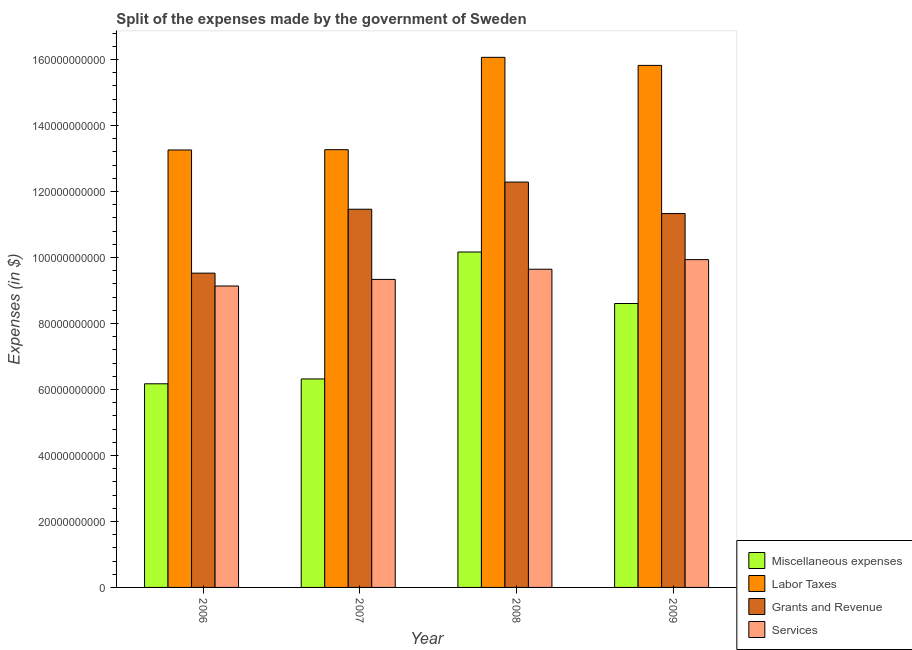How many bars are there on the 1st tick from the right?
Make the answer very short. 4. What is the label of the 2nd group of bars from the left?
Provide a short and direct response. 2007. In how many cases, is the number of bars for a given year not equal to the number of legend labels?
Your answer should be compact. 0. What is the amount spent on miscellaneous expenses in 2006?
Give a very brief answer. 6.17e+1. Across all years, what is the maximum amount spent on labor taxes?
Ensure brevity in your answer.  1.61e+11. Across all years, what is the minimum amount spent on services?
Make the answer very short. 9.14e+1. In which year was the amount spent on grants and revenue maximum?
Make the answer very short. 2008. In which year was the amount spent on services minimum?
Your answer should be compact. 2006. What is the total amount spent on services in the graph?
Your response must be concise. 3.81e+11. What is the difference between the amount spent on grants and revenue in 2007 and that in 2008?
Make the answer very short. -8.23e+09. What is the difference between the amount spent on grants and revenue in 2008 and the amount spent on miscellaneous expenses in 2007?
Ensure brevity in your answer.  8.23e+09. What is the average amount spent on services per year?
Keep it short and to the point. 9.51e+1. In how many years, is the amount spent on labor taxes greater than 52000000000 $?
Offer a very short reply. 4. What is the ratio of the amount spent on labor taxes in 2007 to that in 2008?
Provide a short and direct response. 0.83. Is the difference between the amount spent on miscellaneous expenses in 2006 and 2007 greater than the difference between the amount spent on grants and revenue in 2006 and 2007?
Offer a very short reply. No. What is the difference between the highest and the second highest amount spent on labor taxes?
Provide a succinct answer. 2.45e+09. What is the difference between the highest and the lowest amount spent on miscellaneous expenses?
Your answer should be compact. 3.99e+1. In how many years, is the amount spent on labor taxes greater than the average amount spent on labor taxes taken over all years?
Provide a short and direct response. 2. Is the sum of the amount spent on labor taxes in 2006 and 2007 greater than the maximum amount spent on miscellaneous expenses across all years?
Provide a short and direct response. Yes. What does the 1st bar from the left in 2007 represents?
Provide a succinct answer. Miscellaneous expenses. What does the 1st bar from the right in 2006 represents?
Your response must be concise. Services. Is it the case that in every year, the sum of the amount spent on miscellaneous expenses and amount spent on labor taxes is greater than the amount spent on grants and revenue?
Ensure brevity in your answer.  Yes. How many bars are there?
Keep it short and to the point. 16. What is the difference between two consecutive major ticks on the Y-axis?
Ensure brevity in your answer.  2.00e+1. Are the values on the major ticks of Y-axis written in scientific E-notation?
Provide a succinct answer. No. Does the graph contain grids?
Give a very brief answer. No. Where does the legend appear in the graph?
Keep it short and to the point. Bottom right. How many legend labels are there?
Your answer should be compact. 4. How are the legend labels stacked?
Offer a very short reply. Vertical. What is the title of the graph?
Offer a very short reply. Split of the expenses made by the government of Sweden. What is the label or title of the Y-axis?
Your answer should be very brief. Expenses (in $). What is the Expenses (in $) of Miscellaneous expenses in 2006?
Provide a succinct answer. 6.17e+1. What is the Expenses (in $) of Labor Taxes in 2006?
Keep it short and to the point. 1.33e+11. What is the Expenses (in $) in Grants and Revenue in 2006?
Your response must be concise. 9.53e+1. What is the Expenses (in $) of Services in 2006?
Keep it short and to the point. 9.14e+1. What is the Expenses (in $) of Miscellaneous expenses in 2007?
Your answer should be very brief. 6.32e+1. What is the Expenses (in $) in Labor Taxes in 2007?
Offer a terse response. 1.33e+11. What is the Expenses (in $) in Grants and Revenue in 2007?
Keep it short and to the point. 1.15e+11. What is the Expenses (in $) in Services in 2007?
Keep it short and to the point. 9.34e+1. What is the Expenses (in $) in Miscellaneous expenses in 2008?
Offer a terse response. 1.02e+11. What is the Expenses (in $) in Labor Taxes in 2008?
Ensure brevity in your answer.  1.61e+11. What is the Expenses (in $) of Grants and Revenue in 2008?
Give a very brief answer. 1.23e+11. What is the Expenses (in $) of Services in 2008?
Keep it short and to the point. 9.65e+1. What is the Expenses (in $) of Miscellaneous expenses in 2009?
Ensure brevity in your answer.  8.61e+1. What is the Expenses (in $) of Labor Taxes in 2009?
Your response must be concise. 1.58e+11. What is the Expenses (in $) in Grants and Revenue in 2009?
Ensure brevity in your answer.  1.13e+11. What is the Expenses (in $) in Services in 2009?
Offer a terse response. 9.94e+1. Across all years, what is the maximum Expenses (in $) of Miscellaneous expenses?
Your answer should be compact. 1.02e+11. Across all years, what is the maximum Expenses (in $) of Labor Taxes?
Make the answer very short. 1.61e+11. Across all years, what is the maximum Expenses (in $) in Grants and Revenue?
Offer a terse response. 1.23e+11. Across all years, what is the maximum Expenses (in $) in Services?
Provide a succinct answer. 9.94e+1. Across all years, what is the minimum Expenses (in $) in Miscellaneous expenses?
Make the answer very short. 6.17e+1. Across all years, what is the minimum Expenses (in $) in Labor Taxes?
Make the answer very short. 1.33e+11. Across all years, what is the minimum Expenses (in $) of Grants and Revenue?
Provide a short and direct response. 9.53e+1. Across all years, what is the minimum Expenses (in $) of Services?
Offer a very short reply. 9.14e+1. What is the total Expenses (in $) in Miscellaneous expenses in the graph?
Ensure brevity in your answer.  3.13e+11. What is the total Expenses (in $) of Labor Taxes in the graph?
Your answer should be compact. 5.84e+11. What is the total Expenses (in $) of Grants and Revenue in the graph?
Ensure brevity in your answer.  4.46e+11. What is the total Expenses (in $) in Services in the graph?
Offer a terse response. 3.81e+11. What is the difference between the Expenses (in $) of Miscellaneous expenses in 2006 and that in 2007?
Offer a terse response. -1.47e+09. What is the difference between the Expenses (in $) in Labor Taxes in 2006 and that in 2007?
Your answer should be compact. -9.40e+07. What is the difference between the Expenses (in $) of Grants and Revenue in 2006 and that in 2007?
Provide a short and direct response. -1.94e+1. What is the difference between the Expenses (in $) in Services in 2006 and that in 2007?
Provide a succinct answer. -2.00e+09. What is the difference between the Expenses (in $) in Miscellaneous expenses in 2006 and that in 2008?
Make the answer very short. -3.99e+1. What is the difference between the Expenses (in $) of Labor Taxes in 2006 and that in 2008?
Ensure brevity in your answer.  -2.81e+1. What is the difference between the Expenses (in $) in Grants and Revenue in 2006 and that in 2008?
Keep it short and to the point. -2.76e+1. What is the difference between the Expenses (in $) of Services in 2006 and that in 2008?
Give a very brief answer. -5.09e+09. What is the difference between the Expenses (in $) in Miscellaneous expenses in 2006 and that in 2009?
Offer a very short reply. -2.43e+1. What is the difference between the Expenses (in $) of Labor Taxes in 2006 and that in 2009?
Ensure brevity in your answer.  -2.56e+1. What is the difference between the Expenses (in $) of Grants and Revenue in 2006 and that in 2009?
Make the answer very short. -1.81e+1. What is the difference between the Expenses (in $) in Services in 2006 and that in 2009?
Provide a short and direct response. -8.00e+09. What is the difference between the Expenses (in $) of Miscellaneous expenses in 2007 and that in 2008?
Keep it short and to the point. -3.85e+1. What is the difference between the Expenses (in $) in Labor Taxes in 2007 and that in 2008?
Your answer should be very brief. -2.80e+1. What is the difference between the Expenses (in $) in Grants and Revenue in 2007 and that in 2008?
Keep it short and to the point. -8.23e+09. What is the difference between the Expenses (in $) of Services in 2007 and that in 2008?
Provide a succinct answer. -3.09e+09. What is the difference between the Expenses (in $) of Miscellaneous expenses in 2007 and that in 2009?
Your answer should be compact. -2.29e+1. What is the difference between the Expenses (in $) of Labor Taxes in 2007 and that in 2009?
Keep it short and to the point. -2.55e+1. What is the difference between the Expenses (in $) of Grants and Revenue in 2007 and that in 2009?
Your answer should be compact. 1.31e+09. What is the difference between the Expenses (in $) in Services in 2007 and that in 2009?
Offer a terse response. -6.00e+09. What is the difference between the Expenses (in $) of Miscellaneous expenses in 2008 and that in 2009?
Make the answer very short. 1.56e+1. What is the difference between the Expenses (in $) in Labor Taxes in 2008 and that in 2009?
Provide a succinct answer. 2.45e+09. What is the difference between the Expenses (in $) of Grants and Revenue in 2008 and that in 2009?
Make the answer very short. 9.54e+09. What is the difference between the Expenses (in $) in Services in 2008 and that in 2009?
Provide a succinct answer. -2.92e+09. What is the difference between the Expenses (in $) of Miscellaneous expenses in 2006 and the Expenses (in $) of Labor Taxes in 2007?
Provide a short and direct response. -7.10e+1. What is the difference between the Expenses (in $) of Miscellaneous expenses in 2006 and the Expenses (in $) of Grants and Revenue in 2007?
Provide a short and direct response. -5.29e+1. What is the difference between the Expenses (in $) in Miscellaneous expenses in 2006 and the Expenses (in $) in Services in 2007?
Provide a succinct answer. -3.16e+1. What is the difference between the Expenses (in $) in Labor Taxes in 2006 and the Expenses (in $) in Grants and Revenue in 2007?
Your answer should be very brief. 1.80e+1. What is the difference between the Expenses (in $) in Labor Taxes in 2006 and the Expenses (in $) in Services in 2007?
Ensure brevity in your answer.  3.92e+1. What is the difference between the Expenses (in $) in Grants and Revenue in 2006 and the Expenses (in $) in Services in 2007?
Provide a succinct answer. 1.90e+09. What is the difference between the Expenses (in $) of Miscellaneous expenses in 2006 and the Expenses (in $) of Labor Taxes in 2008?
Provide a succinct answer. -9.90e+1. What is the difference between the Expenses (in $) of Miscellaneous expenses in 2006 and the Expenses (in $) of Grants and Revenue in 2008?
Give a very brief answer. -6.11e+1. What is the difference between the Expenses (in $) of Miscellaneous expenses in 2006 and the Expenses (in $) of Services in 2008?
Offer a very short reply. -3.47e+1. What is the difference between the Expenses (in $) of Labor Taxes in 2006 and the Expenses (in $) of Grants and Revenue in 2008?
Ensure brevity in your answer.  9.73e+09. What is the difference between the Expenses (in $) of Labor Taxes in 2006 and the Expenses (in $) of Services in 2008?
Offer a very short reply. 3.61e+1. What is the difference between the Expenses (in $) in Grants and Revenue in 2006 and the Expenses (in $) in Services in 2008?
Keep it short and to the point. -1.19e+09. What is the difference between the Expenses (in $) of Miscellaneous expenses in 2006 and the Expenses (in $) of Labor Taxes in 2009?
Your answer should be very brief. -9.65e+1. What is the difference between the Expenses (in $) in Miscellaneous expenses in 2006 and the Expenses (in $) in Grants and Revenue in 2009?
Offer a terse response. -5.16e+1. What is the difference between the Expenses (in $) of Miscellaneous expenses in 2006 and the Expenses (in $) of Services in 2009?
Ensure brevity in your answer.  -3.76e+1. What is the difference between the Expenses (in $) in Labor Taxes in 2006 and the Expenses (in $) in Grants and Revenue in 2009?
Offer a very short reply. 1.93e+1. What is the difference between the Expenses (in $) of Labor Taxes in 2006 and the Expenses (in $) of Services in 2009?
Ensure brevity in your answer.  3.32e+1. What is the difference between the Expenses (in $) in Grants and Revenue in 2006 and the Expenses (in $) in Services in 2009?
Provide a short and direct response. -4.10e+09. What is the difference between the Expenses (in $) of Miscellaneous expenses in 2007 and the Expenses (in $) of Labor Taxes in 2008?
Your response must be concise. -9.75e+1. What is the difference between the Expenses (in $) in Miscellaneous expenses in 2007 and the Expenses (in $) in Grants and Revenue in 2008?
Ensure brevity in your answer.  -5.97e+1. What is the difference between the Expenses (in $) of Miscellaneous expenses in 2007 and the Expenses (in $) of Services in 2008?
Your response must be concise. -3.33e+1. What is the difference between the Expenses (in $) in Labor Taxes in 2007 and the Expenses (in $) in Grants and Revenue in 2008?
Offer a very short reply. 9.82e+09. What is the difference between the Expenses (in $) of Labor Taxes in 2007 and the Expenses (in $) of Services in 2008?
Your answer should be very brief. 3.62e+1. What is the difference between the Expenses (in $) of Grants and Revenue in 2007 and the Expenses (in $) of Services in 2008?
Provide a short and direct response. 1.82e+1. What is the difference between the Expenses (in $) of Miscellaneous expenses in 2007 and the Expenses (in $) of Labor Taxes in 2009?
Offer a terse response. -9.50e+1. What is the difference between the Expenses (in $) in Miscellaneous expenses in 2007 and the Expenses (in $) in Grants and Revenue in 2009?
Your answer should be very brief. -5.01e+1. What is the difference between the Expenses (in $) of Miscellaneous expenses in 2007 and the Expenses (in $) of Services in 2009?
Your answer should be very brief. -3.62e+1. What is the difference between the Expenses (in $) of Labor Taxes in 2007 and the Expenses (in $) of Grants and Revenue in 2009?
Your answer should be compact. 1.94e+1. What is the difference between the Expenses (in $) of Labor Taxes in 2007 and the Expenses (in $) of Services in 2009?
Offer a terse response. 3.33e+1. What is the difference between the Expenses (in $) in Grants and Revenue in 2007 and the Expenses (in $) in Services in 2009?
Offer a very short reply. 1.53e+1. What is the difference between the Expenses (in $) of Miscellaneous expenses in 2008 and the Expenses (in $) of Labor Taxes in 2009?
Offer a very short reply. -5.66e+1. What is the difference between the Expenses (in $) of Miscellaneous expenses in 2008 and the Expenses (in $) of Grants and Revenue in 2009?
Your answer should be compact. -1.17e+1. What is the difference between the Expenses (in $) in Miscellaneous expenses in 2008 and the Expenses (in $) in Services in 2009?
Offer a very short reply. 2.30e+09. What is the difference between the Expenses (in $) of Labor Taxes in 2008 and the Expenses (in $) of Grants and Revenue in 2009?
Give a very brief answer. 4.74e+1. What is the difference between the Expenses (in $) in Labor Taxes in 2008 and the Expenses (in $) in Services in 2009?
Ensure brevity in your answer.  6.13e+1. What is the difference between the Expenses (in $) of Grants and Revenue in 2008 and the Expenses (in $) of Services in 2009?
Make the answer very short. 2.35e+1. What is the average Expenses (in $) of Miscellaneous expenses per year?
Your response must be concise. 7.82e+1. What is the average Expenses (in $) of Labor Taxes per year?
Offer a terse response. 1.46e+11. What is the average Expenses (in $) in Grants and Revenue per year?
Provide a short and direct response. 1.12e+11. What is the average Expenses (in $) in Services per year?
Your response must be concise. 9.51e+1. In the year 2006, what is the difference between the Expenses (in $) of Miscellaneous expenses and Expenses (in $) of Labor Taxes?
Provide a short and direct response. -7.09e+1. In the year 2006, what is the difference between the Expenses (in $) of Miscellaneous expenses and Expenses (in $) of Grants and Revenue?
Provide a short and direct response. -3.35e+1. In the year 2006, what is the difference between the Expenses (in $) of Miscellaneous expenses and Expenses (in $) of Services?
Your response must be concise. -2.96e+1. In the year 2006, what is the difference between the Expenses (in $) in Labor Taxes and Expenses (in $) in Grants and Revenue?
Keep it short and to the point. 3.73e+1. In the year 2006, what is the difference between the Expenses (in $) in Labor Taxes and Expenses (in $) in Services?
Offer a terse response. 4.12e+1. In the year 2006, what is the difference between the Expenses (in $) of Grants and Revenue and Expenses (in $) of Services?
Your answer should be very brief. 3.90e+09. In the year 2007, what is the difference between the Expenses (in $) of Miscellaneous expenses and Expenses (in $) of Labor Taxes?
Keep it short and to the point. -6.95e+1. In the year 2007, what is the difference between the Expenses (in $) of Miscellaneous expenses and Expenses (in $) of Grants and Revenue?
Provide a succinct answer. -5.14e+1. In the year 2007, what is the difference between the Expenses (in $) in Miscellaneous expenses and Expenses (in $) in Services?
Your answer should be very brief. -3.02e+1. In the year 2007, what is the difference between the Expenses (in $) in Labor Taxes and Expenses (in $) in Grants and Revenue?
Offer a terse response. 1.81e+1. In the year 2007, what is the difference between the Expenses (in $) of Labor Taxes and Expenses (in $) of Services?
Provide a succinct answer. 3.93e+1. In the year 2007, what is the difference between the Expenses (in $) of Grants and Revenue and Expenses (in $) of Services?
Your answer should be compact. 2.13e+1. In the year 2008, what is the difference between the Expenses (in $) of Miscellaneous expenses and Expenses (in $) of Labor Taxes?
Provide a succinct answer. -5.90e+1. In the year 2008, what is the difference between the Expenses (in $) in Miscellaneous expenses and Expenses (in $) in Grants and Revenue?
Offer a very short reply. -2.12e+1. In the year 2008, what is the difference between the Expenses (in $) of Miscellaneous expenses and Expenses (in $) of Services?
Your answer should be very brief. 5.22e+09. In the year 2008, what is the difference between the Expenses (in $) in Labor Taxes and Expenses (in $) in Grants and Revenue?
Make the answer very short. 3.78e+1. In the year 2008, what is the difference between the Expenses (in $) in Labor Taxes and Expenses (in $) in Services?
Your response must be concise. 6.42e+1. In the year 2008, what is the difference between the Expenses (in $) of Grants and Revenue and Expenses (in $) of Services?
Make the answer very short. 2.64e+1. In the year 2009, what is the difference between the Expenses (in $) of Miscellaneous expenses and Expenses (in $) of Labor Taxes?
Offer a terse response. -7.22e+1. In the year 2009, what is the difference between the Expenses (in $) in Miscellaneous expenses and Expenses (in $) in Grants and Revenue?
Keep it short and to the point. -2.73e+1. In the year 2009, what is the difference between the Expenses (in $) in Miscellaneous expenses and Expenses (in $) in Services?
Keep it short and to the point. -1.33e+1. In the year 2009, what is the difference between the Expenses (in $) in Labor Taxes and Expenses (in $) in Grants and Revenue?
Your response must be concise. 4.49e+1. In the year 2009, what is the difference between the Expenses (in $) in Labor Taxes and Expenses (in $) in Services?
Give a very brief answer. 5.89e+1. In the year 2009, what is the difference between the Expenses (in $) in Grants and Revenue and Expenses (in $) in Services?
Give a very brief answer. 1.40e+1. What is the ratio of the Expenses (in $) in Miscellaneous expenses in 2006 to that in 2007?
Your answer should be compact. 0.98. What is the ratio of the Expenses (in $) of Grants and Revenue in 2006 to that in 2007?
Keep it short and to the point. 0.83. What is the ratio of the Expenses (in $) of Services in 2006 to that in 2007?
Ensure brevity in your answer.  0.98. What is the ratio of the Expenses (in $) in Miscellaneous expenses in 2006 to that in 2008?
Make the answer very short. 0.61. What is the ratio of the Expenses (in $) of Labor Taxes in 2006 to that in 2008?
Ensure brevity in your answer.  0.83. What is the ratio of the Expenses (in $) in Grants and Revenue in 2006 to that in 2008?
Offer a terse response. 0.78. What is the ratio of the Expenses (in $) in Services in 2006 to that in 2008?
Your answer should be very brief. 0.95. What is the ratio of the Expenses (in $) of Miscellaneous expenses in 2006 to that in 2009?
Provide a short and direct response. 0.72. What is the ratio of the Expenses (in $) of Labor Taxes in 2006 to that in 2009?
Offer a terse response. 0.84. What is the ratio of the Expenses (in $) of Grants and Revenue in 2006 to that in 2009?
Keep it short and to the point. 0.84. What is the ratio of the Expenses (in $) in Services in 2006 to that in 2009?
Make the answer very short. 0.92. What is the ratio of the Expenses (in $) in Miscellaneous expenses in 2007 to that in 2008?
Make the answer very short. 0.62. What is the ratio of the Expenses (in $) in Labor Taxes in 2007 to that in 2008?
Offer a terse response. 0.83. What is the ratio of the Expenses (in $) in Grants and Revenue in 2007 to that in 2008?
Your answer should be compact. 0.93. What is the ratio of the Expenses (in $) of Services in 2007 to that in 2008?
Make the answer very short. 0.97. What is the ratio of the Expenses (in $) of Miscellaneous expenses in 2007 to that in 2009?
Provide a succinct answer. 0.73. What is the ratio of the Expenses (in $) of Labor Taxes in 2007 to that in 2009?
Keep it short and to the point. 0.84. What is the ratio of the Expenses (in $) of Grants and Revenue in 2007 to that in 2009?
Ensure brevity in your answer.  1.01. What is the ratio of the Expenses (in $) of Services in 2007 to that in 2009?
Ensure brevity in your answer.  0.94. What is the ratio of the Expenses (in $) in Miscellaneous expenses in 2008 to that in 2009?
Your answer should be very brief. 1.18. What is the ratio of the Expenses (in $) in Labor Taxes in 2008 to that in 2009?
Make the answer very short. 1.02. What is the ratio of the Expenses (in $) of Grants and Revenue in 2008 to that in 2009?
Your answer should be compact. 1.08. What is the ratio of the Expenses (in $) in Services in 2008 to that in 2009?
Offer a very short reply. 0.97. What is the difference between the highest and the second highest Expenses (in $) in Miscellaneous expenses?
Your answer should be very brief. 1.56e+1. What is the difference between the highest and the second highest Expenses (in $) in Labor Taxes?
Your response must be concise. 2.45e+09. What is the difference between the highest and the second highest Expenses (in $) of Grants and Revenue?
Provide a succinct answer. 8.23e+09. What is the difference between the highest and the second highest Expenses (in $) of Services?
Keep it short and to the point. 2.92e+09. What is the difference between the highest and the lowest Expenses (in $) of Miscellaneous expenses?
Keep it short and to the point. 3.99e+1. What is the difference between the highest and the lowest Expenses (in $) of Labor Taxes?
Provide a succinct answer. 2.81e+1. What is the difference between the highest and the lowest Expenses (in $) in Grants and Revenue?
Your response must be concise. 2.76e+1. What is the difference between the highest and the lowest Expenses (in $) in Services?
Provide a short and direct response. 8.00e+09. 